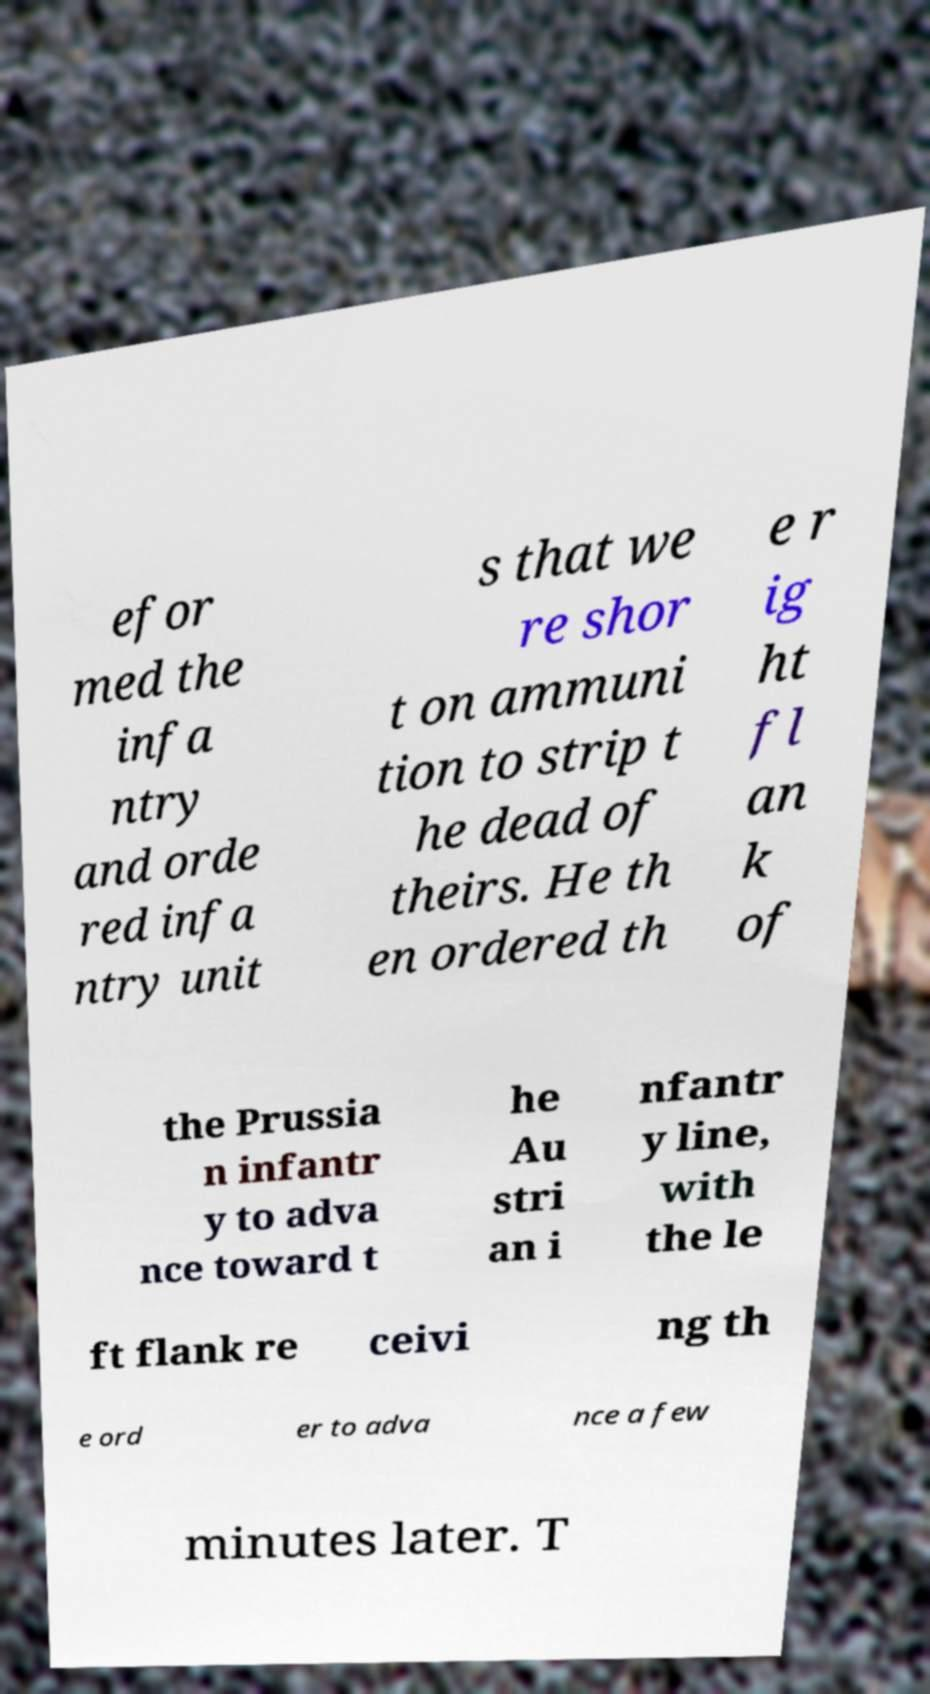Can you read and provide the text displayed in the image?This photo seems to have some interesting text. Can you extract and type it out for me? efor med the infa ntry and orde red infa ntry unit s that we re shor t on ammuni tion to strip t he dead of theirs. He th en ordered th e r ig ht fl an k of the Prussia n infantr y to adva nce toward t he Au stri an i nfantr y line, with the le ft flank re ceivi ng th e ord er to adva nce a few minutes later. T 